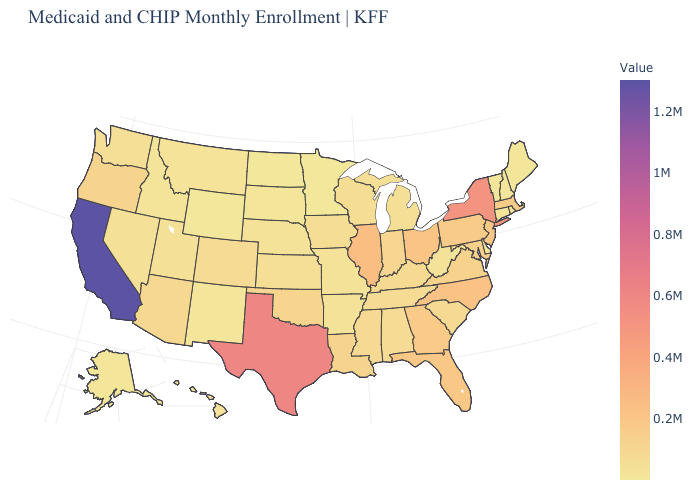Is the legend a continuous bar?
Quick response, please. Yes. Among the states that border Oklahoma , which have the lowest value?
Give a very brief answer. New Mexico. Among the states that border Utah , does Idaho have the highest value?
Write a very short answer. No. Among the states that border Oregon , does Washington have the lowest value?
Concise answer only. No. Does California have the highest value in the USA?
Quick response, please. Yes. 